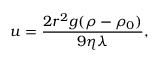<formula> <loc_0><loc_0><loc_500><loc_500>u = \frac { 2 r ^ { 2 } g ( \rho - \rho _ { 0 } ) } { 9 \eta \lambda } ,</formula> 